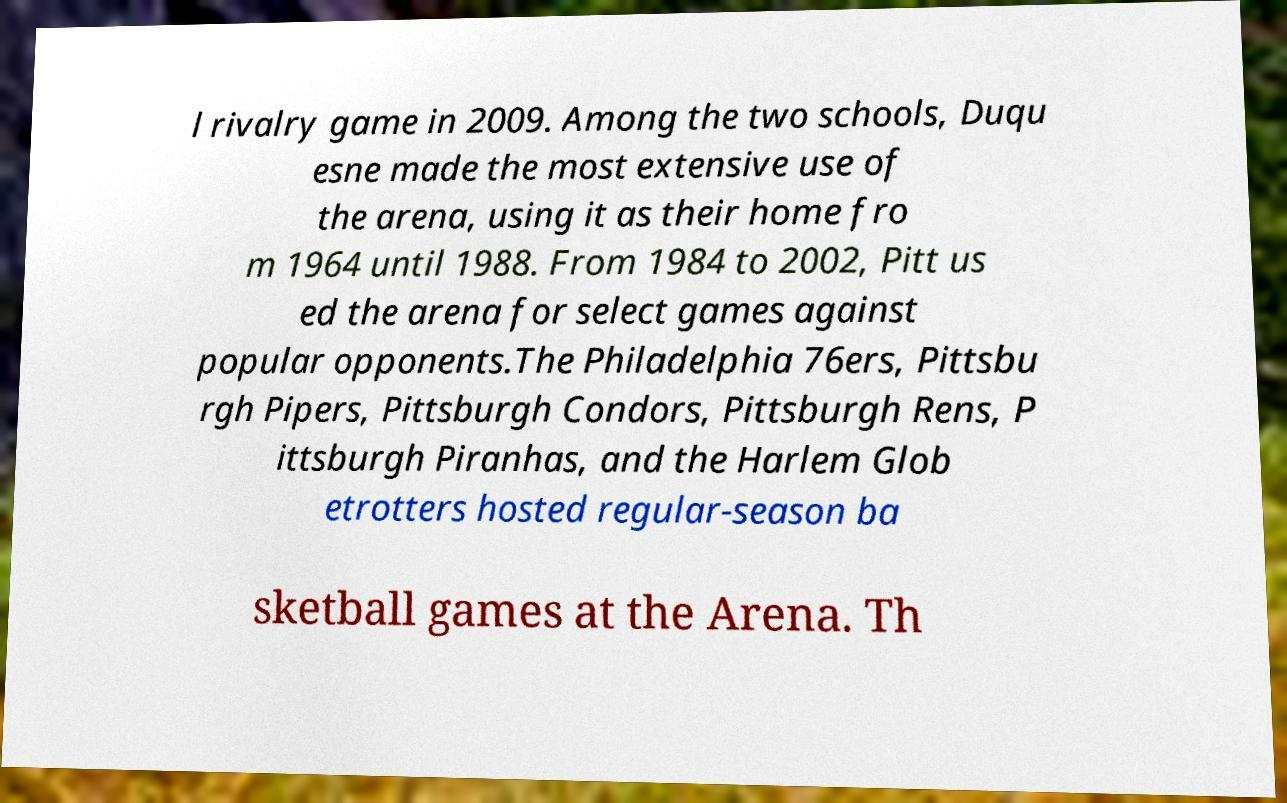There's text embedded in this image that I need extracted. Can you transcribe it verbatim? l rivalry game in 2009. Among the two schools, Duqu esne made the most extensive use of the arena, using it as their home fro m 1964 until 1988. From 1984 to 2002, Pitt us ed the arena for select games against popular opponents.The Philadelphia 76ers, Pittsbu rgh Pipers, Pittsburgh Condors, Pittsburgh Rens, P ittsburgh Piranhas, and the Harlem Glob etrotters hosted regular-season ba sketball games at the Arena. Th 